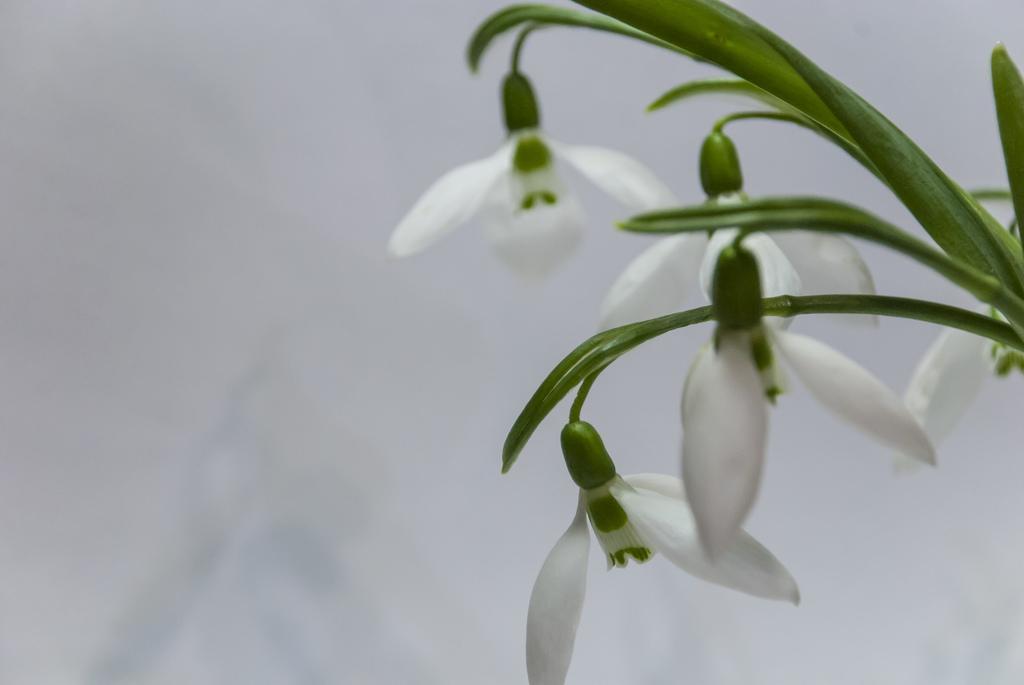Please provide a concise description of this image. In this picture there are white color flowers on the plant. At the back the image is blurry. 